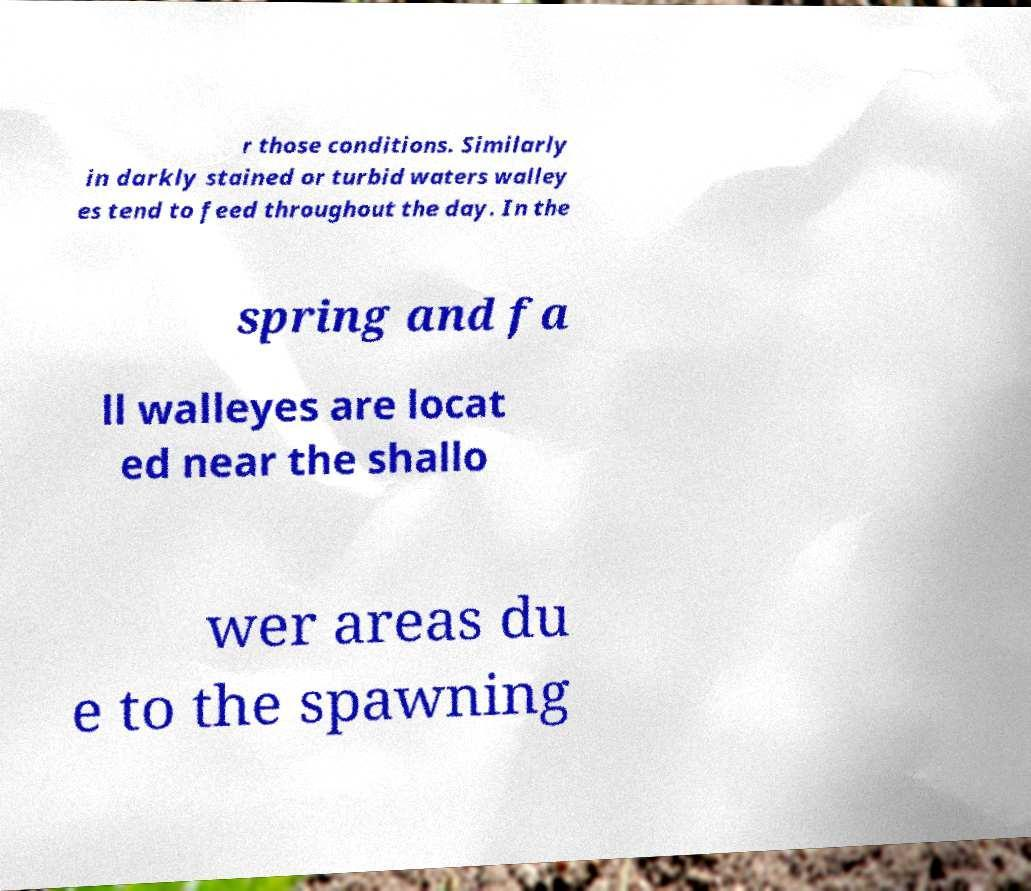Can you accurately transcribe the text from the provided image for me? r those conditions. Similarly in darkly stained or turbid waters walley es tend to feed throughout the day. In the spring and fa ll walleyes are locat ed near the shallo wer areas du e to the spawning 